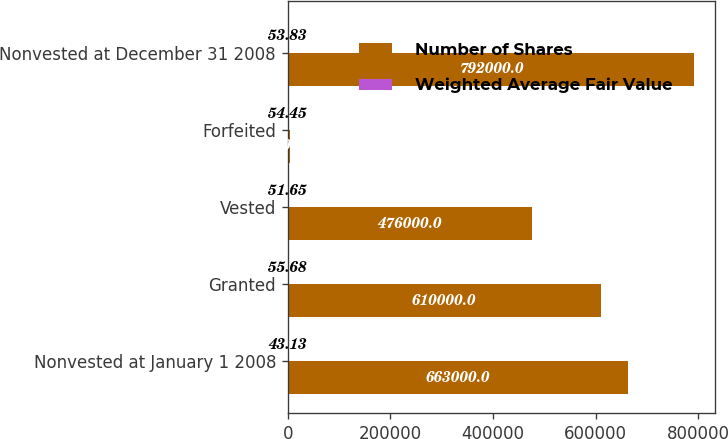<chart> <loc_0><loc_0><loc_500><loc_500><stacked_bar_chart><ecel><fcel>Nonvested at January 1 2008<fcel>Granted<fcel>Vested<fcel>Forfeited<fcel>Nonvested at December 31 2008<nl><fcel>Number of Shares<fcel>663000<fcel>610000<fcel>476000<fcel>5000<fcel>792000<nl><fcel>Weighted Average Fair Value<fcel>43.13<fcel>55.68<fcel>51.65<fcel>54.45<fcel>53.83<nl></chart> 